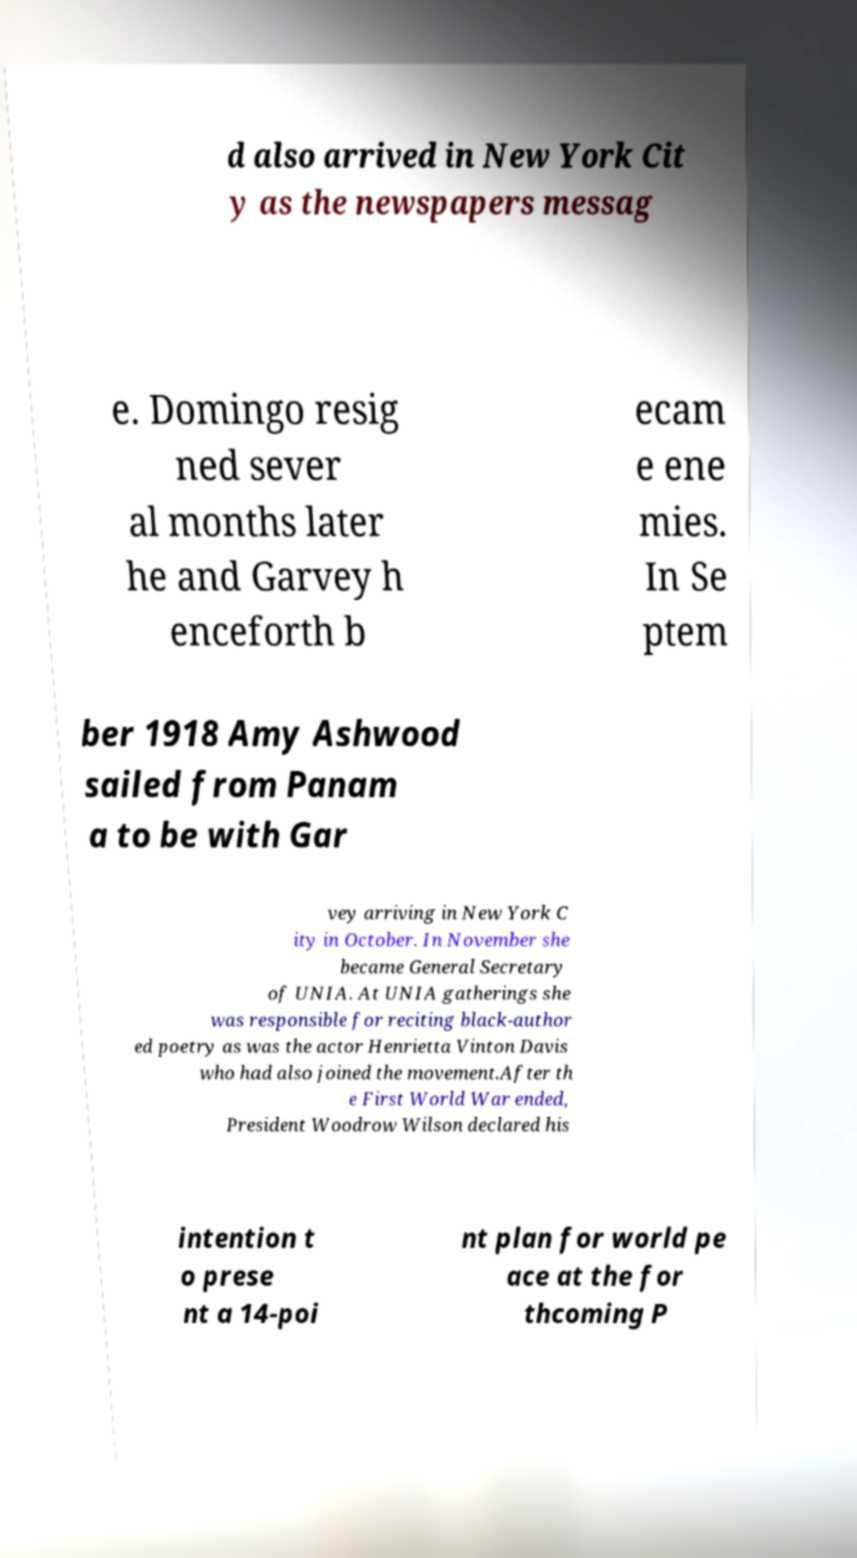Can you read and provide the text displayed in the image?This photo seems to have some interesting text. Can you extract and type it out for me? d also arrived in New York Cit y as the newspapers messag e. Domingo resig ned sever al months later he and Garvey h enceforth b ecam e ene mies. In Se ptem ber 1918 Amy Ashwood sailed from Panam a to be with Gar vey arriving in New York C ity in October. In November she became General Secretary of UNIA. At UNIA gatherings she was responsible for reciting black-author ed poetry as was the actor Henrietta Vinton Davis who had also joined the movement.After th e First World War ended, President Woodrow Wilson declared his intention t o prese nt a 14-poi nt plan for world pe ace at the for thcoming P 